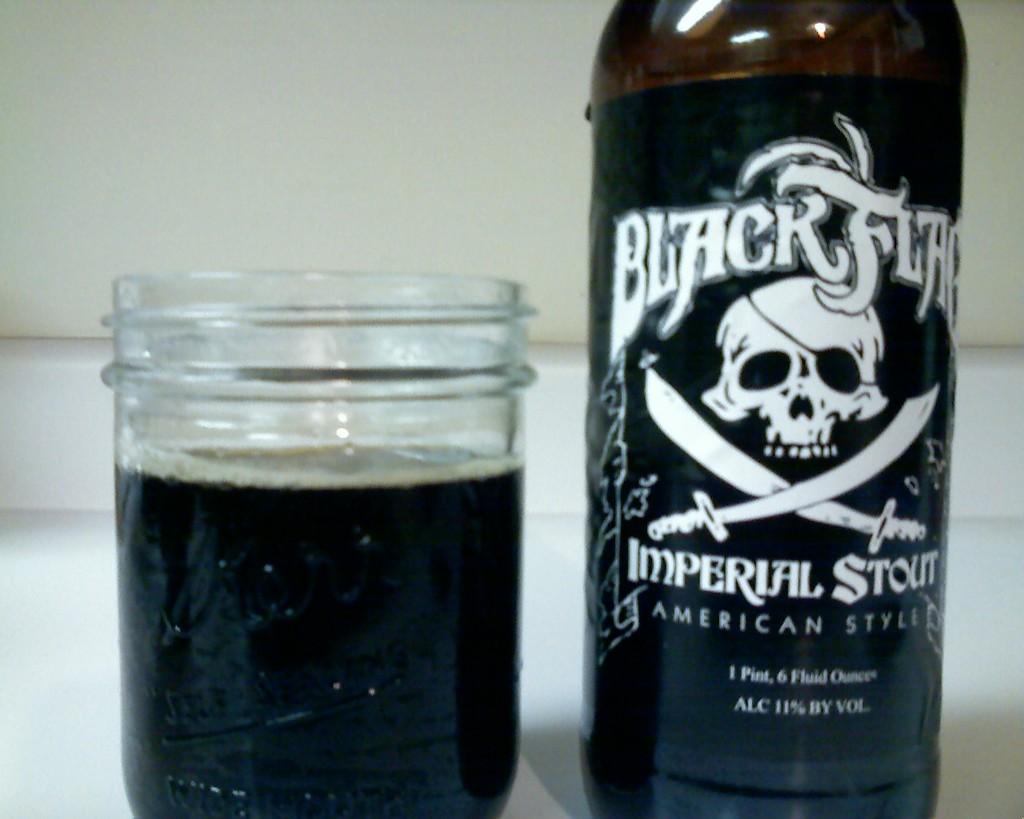What is the brand of beer?
Ensure brevity in your answer.  Black flag. What is the alcohol content of the beer?
Offer a very short reply. 11%. 